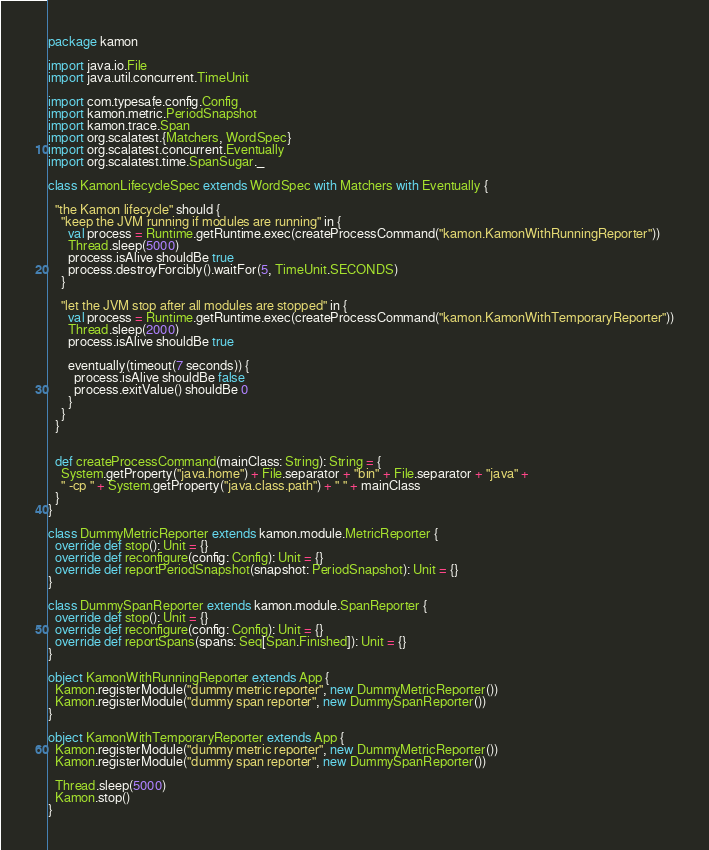<code> <loc_0><loc_0><loc_500><loc_500><_Scala_>package kamon

import java.io.File
import java.util.concurrent.TimeUnit

import com.typesafe.config.Config
import kamon.metric.PeriodSnapshot
import kamon.trace.Span
import org.scalatest.{Matchers, WordSpec}
import org.scalatest.concurrent.Eventually
import org.scalatest.time.SpanSugar._

class KamonLifecycleSpec extends WordSpec with Matchers with Eventually {

  "the Kamon lifecycle" should {
    "keep the JVM running if modules are running" in {
      val process = Runtime.getRuntime.exec(createProcessCommand("kamon.KamonWithRunningReporter"))
      Thread.sleep(5000)
      process.isAlive shouldBe true
      process.destroyForcibly().waitFor(5, TimeUnit.SECONDS)
    }

    "let the JVM stop after all modules are stopped" in {
      val process = Runtime.getRuntime.exec(createProcessCommand("kamon.KamonWithTemporaryReporter"))
      Thread.sleep(2000)
      process.isAlive shouldBe true

      eventually(timeout(7 seconds)) {
        process.isAlive shouldBe false
        process.exitValue() shouldBe 0
      }
    }
  }


  def createProcessCommand(mainClass: String): String = {
    System.getProperty("java.home") + File.separator + "bin" + File.separator + "java" +
    " -cp " + System.getProperty("java.class.path") + " " + mainClass
  }
}

class DummyMetricReporter extends kamon.module.MetricReporter {
  override def stop(): Unit = {}
  override def reconfigure(config: Config): Unit = {}
  override def reportPeriodSnapshot(snapshot: PeriodSnapshot): Unit = {}
}

class DummySpanReporter extends kamon.module.SpanReporter {
  override def stop(): Unit = {}
  override def reconfigure(config: Config): Unit = {}
  override def reportSpans(spans: Seq[Span.Finished]): Unit = {}
}

object KamonWithRunningReporter extends App {
  Kamon.registerModule("dummy metric reporter", new DummyMetricReporter())
  Kamon.registerModule("dummy span reporter", new DummySpanReporter())
}

object KamonWithTemporaryReporter extends App {
  Kamon.registerModule("dummy metric reporter", new DummyMetricReporter())
  Kamon.registerModule("dummy span reporter", new DummySpanReporter())

  Thread.sleep(5000)
  Kamon.stop()
}
</code> 